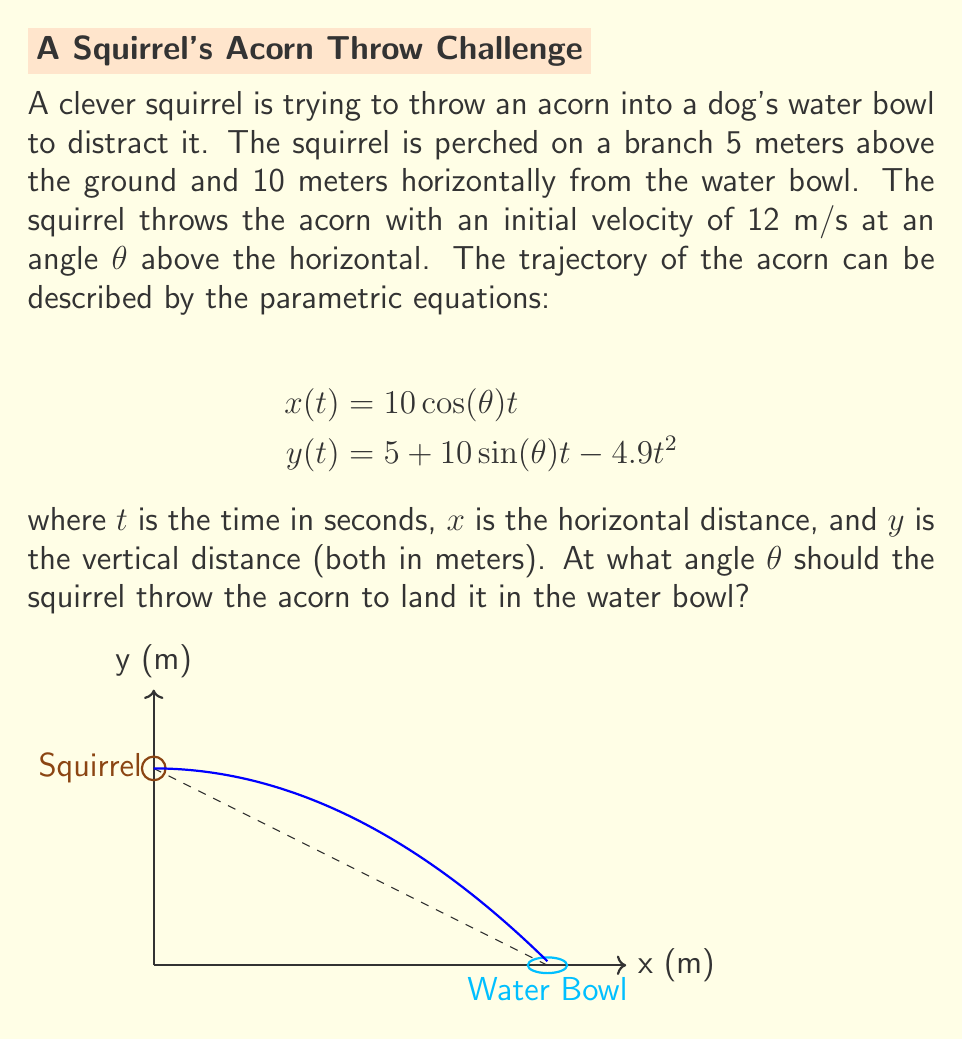Help me with this question. Let's approach this step-by-step:

1) We know that the acorn needs to land in the water bowl, which is 10 meters away horizontally and at ground level (y = 0). So, we need to find t and θ such that:

   $$x(t) = 10$$ and $$y(t) = 0$$

2) From the x equation:
   $$10 = 10 \cos(\theta) t$$
   $$t = \frac{1}{\cos(\theta)}$$

3) Substituting this into the y equation:
   $$0 = 5 + 10 \sin(\theta) (\frac{1}{\cos(\theta)}) - 4.9(\frac{1}{\cos(\theta)})^2$$

4) Simplifying:
   $$0 = 5 + 10 \tan(\theta) - \frac{4.9}{\cos^2(\theta)}$$

5) Multiply both sides by $\cos^2(\theta)$:
   $$0 = 5\cos^2(\theta) + 10\sin(\theta)\cos(\theta) - 4.9$$

6) Use the identity $\sin(2\theta) = 2\sin(\theta)\cos(\theta)$:
   $$0 = 5\cos^2(\theta) + 5\sin(2\theta) - 4.9$$

7) Use the identity $\cos^2(\theta) = \frac{1 + \cos(2\theta)}{2}$:
   $$0 = 5(\frac{1 + \cos(2\theta)}{2}) + 5\sin(2\theta) - 4.9$$

8) Simplify:
   $$0 = 2.5 + 2.5\cos(2\theta) + 5\sin(2\theta) - 4.9$$
   $$2.4 = 2.5\cos(2\theta) + 5\sin(2\theta)$$

9) Divide both sides by 5:
   $$0.48 = 0.5\cos(2\theta) + \sin(2\theta)$$

10) This is in the form $a\cos(2\theta) + b\sin(2\theta) = c$, which has the solution:
    $$2\theta = \arctan(\frac{b}{a}) \pm \arccos(\frac{c}{\sqrt{a^2 + b^2}})$$

11) Substituting our values:
    $$2\theta = \arctan(2) \pm \arccos(\frac{0.48}{\sqrt{0.5^2 + 1^2}})$$

12) Solving this:
    $$2\theta \approx 1.107 + 1.047 = 2.154$$
    $$\theta \approx 1.077 \text{ radians} \approx 61.7°$$
Answer: $61.7°$ 